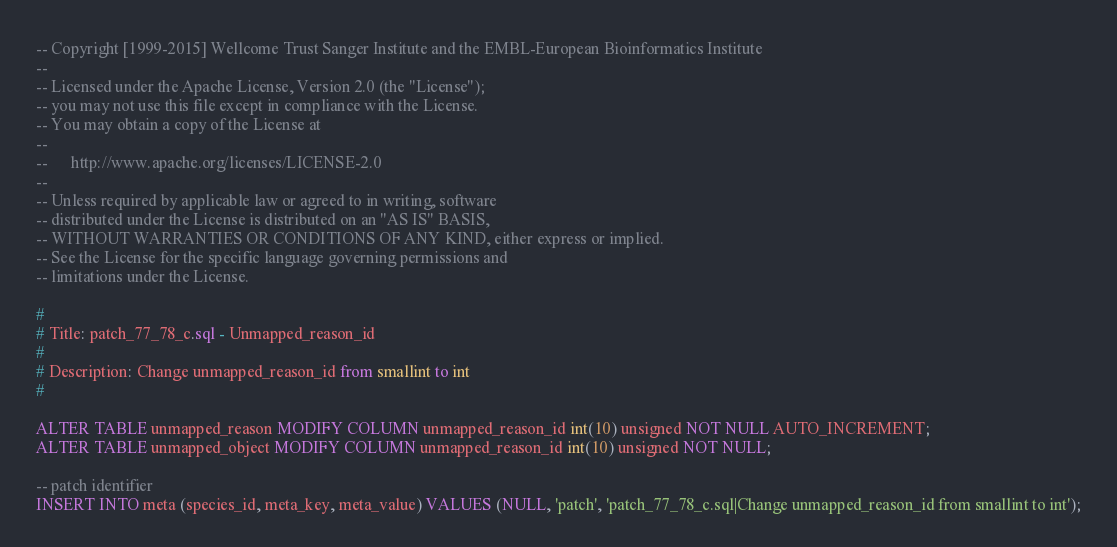<code> <loc_0><loc_0><loc_500><loc_500><_SQL_>-- Copyright [1999-2015] Wellcome Trust Sanger Institute and the EMBL-European Bioinformatics Institute
--
-- Licensed under the Apache License, Version 2.0 (the "License");
-- you may not use this file except in compliance with the License.
-- You may obtain a copy of the License at
--
--      http://www.apache.org/licenses/LICENSE-2.0
--
-- Unless required by applicable law or agreed to in writing, software
-- distributed under the License is distributed on an "AS IS" BASIS,
-- WITHOUT WARRANTIES OR CONDITIONS OF ANY KIND, either express or implied.
-- See the License for the specific language governing permissions and
-- limitations under the License.

#
# Title: patch_77_78_c.sql - Unmapped_reason_id
#
# Description: Change unmapped_reason_id from smallint to int
#   

ALTER TABLE unmapped_reason MODIFY COLUMN unmapped_reason_id int(10) unsigned NOT NULL AUTO_INCREMENT;
ALTER TABLE unmapped_object MODIFY COLUMN unmapped_reason_id int(10) unsigned NOT NULL;

-- patch identifier
INSERT INTO meta (species_id, meta_key, meta_value) VALUES (NULL, 'patch', 'patch_77_78_c.sql|Change unmapped_reason_id from smallint to int');
</code> 